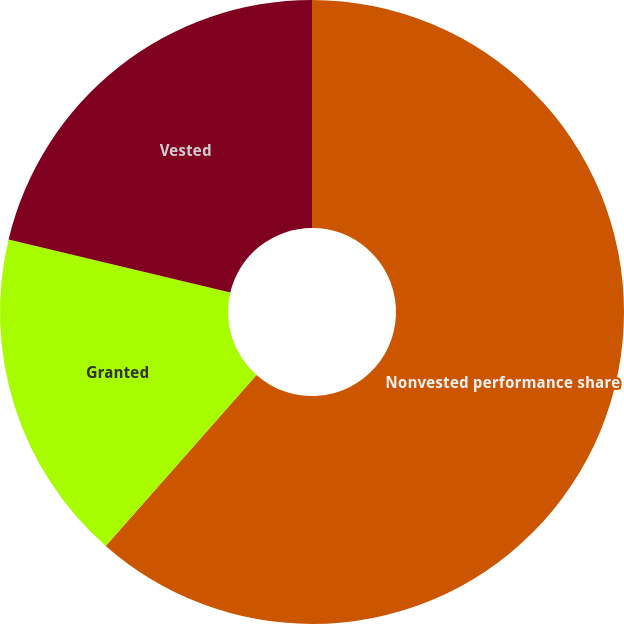Convert chart to OTSL. <chart><loc_0><loc_0><loc_500><loc_500><pie_chart><fcel>Nonvested performance share<fcel>Granted<fcel>Vested<nl><fcel>61.49%<fcel>17.24%<fcel>21.26%<nl></chart> 